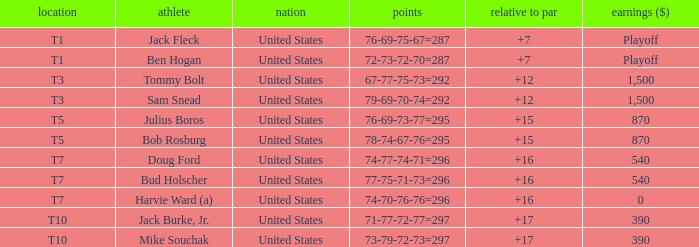What is average to par when Bud Holscher is the player? 16.0. 